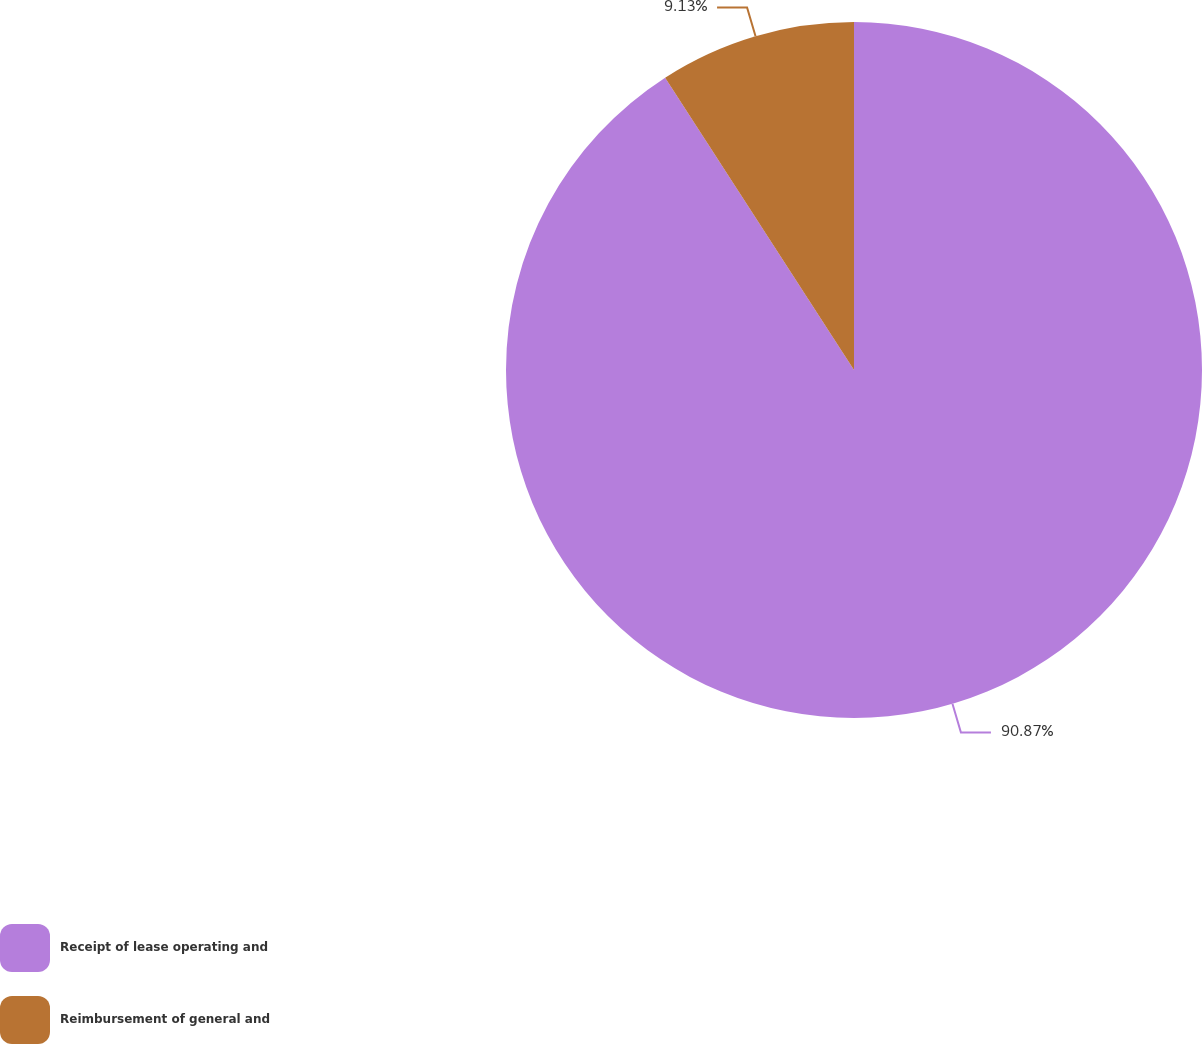Convert chart. <chart><loc_0><loc_0><loc_500><loc_500><pie_chart><fcel>Receipt of lease operating and<fcel>Reimbursement of general and<nl><fcel>90.87%<fcel>9.13%<nl></chart> 